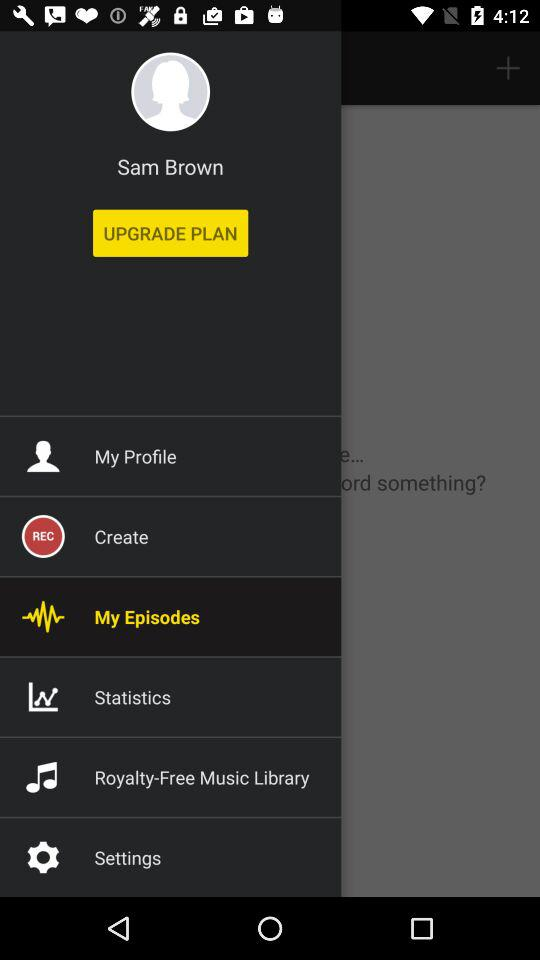Which songs are in the royalty-free music library?
When the provided information is insufficient, respond with <no answer>. <no answer> 